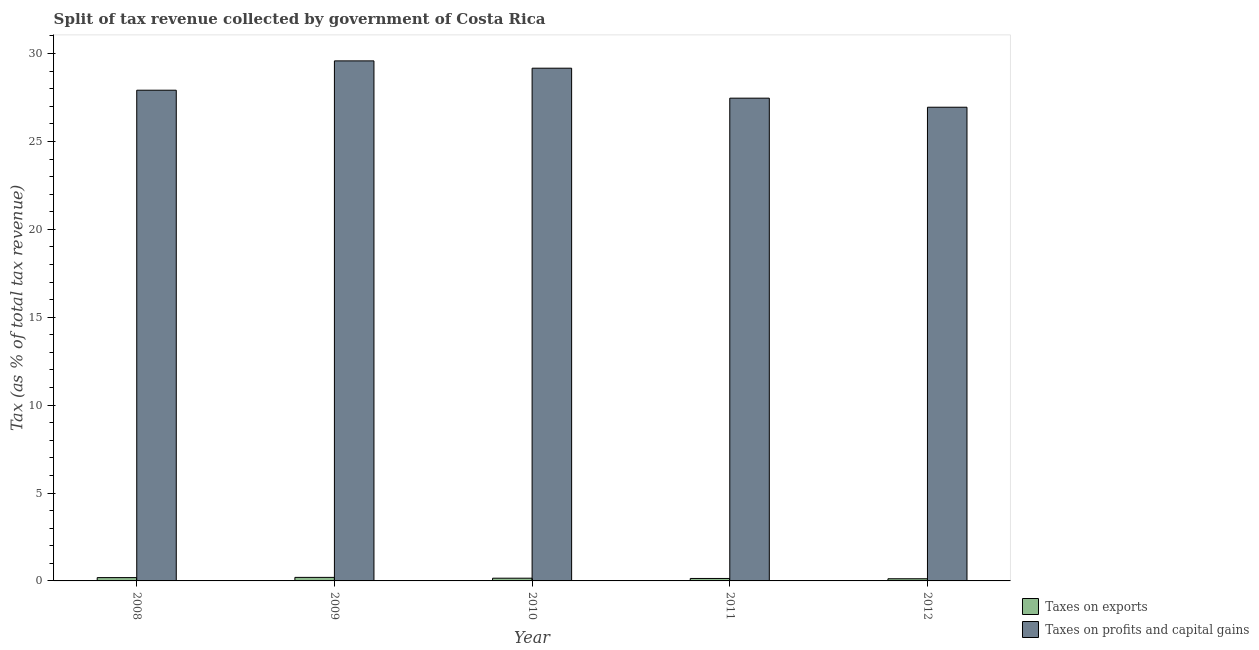How many different coloured bars are there?
Make the answer very short. 2. How many groups of bars are there?
Your response must be concise. 5. How many bars are there on the 4th tick from the right?
Your answer should be compact. 2. In how many cases, is the number of bars for a given year not equal to the number of legend labels?
Your response must be concise. 0. What is the percentage of revenue obtained from taxes on exports in 2010?
Your response must be concise. 0.15. Across all years, what is the maximum percentage of revenue obtained from taxes on profits and capital gains?
Keep it short and to the point. 29.58. Across all years, what is the minimum percentage of revenue obtained from taxes on profits and capital gains?
Provide a short and direct response. 26.95. In which year was the percentage of revenue obtained from taxes on profits and capital gains maximum?
Offer a terse response. 2009. In which year was the percentage of revenue obtained from taxes on profits and capital gains minimum?
Ensure brevity in your answer.  2012. What is the total percentage of revenue obtained from taxes on exports in the graph?
Make the answer very short. 0.81. What is the difference between the percentage of revenue obtained from taxes on exports in 2008 and that in 2012?
Offer a very short reply. 0.07. What is the difference between the percentage of revenue obtained from taxes on exports in 2008 and the percentage of revenue obtained from taxes on profits and capital gains in 2012?
Keep it short and to the point. 0.07. What is the average percentage of revenue obtained from taxes on exports per year?
Keep it short and to the point. 0.16. In how many years, is the percentage of revenue obtained from taxes on profits and capital gains greater than 8 %?
Give a very brief answer. 5. What is the ratio of the percentage of revenue obtained from taxes on exports in 2008 to that in 2011?
Ensure brevity in your answer.  1.35. Is the percentage of revenue obtained from taxes on exports in 2009 less than that in 2012?
Make the answer very short. No. Is the difference between the percentage of revenue obtained from taxes on profits and capital gains in 2008 and 2009 greater than the difference between the percentage of revenue obtained from taxes on exports in 2008 and 2009?
Provide a short and direct response. No. What is the difference between the highest and the second highest percentage of revenue obtained from taxes on profits and capital gains?
Your answer should be very brief. 0.42. What is the difference between the highest and the lowest percentage of revenue obtained from taxes on exports?
Your answer should be compact. 0.08. Is the sum of the percentage of revenue obtained from taxes on exports in 2009 and 2011 greater than the maximum percentage of revenue obtained from taxes on profits and capital gains across all years?
Keep it short and to the point. Yes. What does the 2nd bar from the left in 2011 represents?
Give a very brief answer. Taxes on profits and capital gains. What does the 2nd bar from the right in 2009 represents?
Your answer should be very brief. Taxes on exports. What is the difference between two consecutive major ticks on the Y-axis?
Offer a terse response. 5. Are the values on the major ticks of Y-axis written in scientific E-notation?
Provide a short and direct response. No. Does the graph contain any zero values?
Offer a very short reply. No. Does the graph contain grids?
Ensure brevity in your answer.  No. How many legend labels are there?
Provide a short and direct response. 2. How are the legend labels stacked?
Ensure brevity in your answer.  Vertical. What is the title of the graph?
Your response must be concise. Split of tax revenue collected by government of Costa Rica. What is the label or title of the X-axis?
Offer a very short reply. Year. What is the label or title of the Y-axis?
Ensure brevity in your answer.  Tax (as % of total tax revenue). What is the Tax (as % of total tax revenue) of Taxes on exports in 2008?
Your response must be concise. 0.19. What is the Tax (as % of total tax revenue) of Taxes on profits and capital gains in 2008?
Your answer should be very brief. 27.91. What is the Tax (as % of total tax revenue) in Taxes on exports in 2009?
Your response must be concise. 0.2. What is the Tax (as % of total tax revenue) in Taxes on profits and capital gains in 2009?
Keep it short and to the point. 29.58. What is the Tax (as % of total tax revenue) of Taxes on exports in 2010?
Your response must be concise. 0.15. What is the Tax (as % of total tax revenue) in Taxes on profits and capital gains in 2010?
Provide a short and direct response. 29.17. What is the Tax (as % of total tax revenue) in Taxes on exports in 2011?
Provide a succinct answer. 0.14. What is the Tax (as % of total tax revenue) of Taxes on profits and capital gains in 2011?
Offer a terse response. 27.46. What is the Tax (as % of total tax revenue) of Taxes on exports in 2012?
Ensure brevity in your answer.  0.12. What is the Tax (as % of total tax revenue) in Taxes on profits and capital gains in 2012?
Keep it short and to the point. 26.95. Across all years, what is the maximum Tax (as % of total tax revenue) in Taxes on exports?
Make the answer very short. 0.2. Across all years, what is the maximum Tax (as % of total tax revenue) in Taxes on profits and capital gains?
Offer a very short reply. 29.58. Across all years, what is the minimum Tax (as % of total tax revenue) in Taxes on exports?
Keep it short and to the point. 0.12. Across all years, what is the minimum Tax (as % of total tax revenue) in Taxes on profits and capital gains?
Your response must be concise. 26.95. What is the total Tax (as % of total tax revenue) of Taxes on exports in the graph?
Make the answer very short. 0.81. What is the total Tax (as % of total tax revenue) of Taxes on profits and capital gains in the graph?
Your response must be concise. 141.07. What is the difference between the Tax (as % of total tax revenue) in Taxes on exports in 2008 and that in 2009?
Provide a short and direct response. -0.01. What is the difference between the Tax (as % of total tax revenue) of Taxes on profits and capital gains in 2008 and that in 2009?
Your answer should be very brief. -1.67. What is the difference between the Tax (as % of total tax revenue) in Taxes on exports in 2008 and that in 2010?
Your response must be concise. 0.03. What is the difference between the Tax (as % of total tax revenue) in Taxes on profits and capital gains in 2008 and that in 2010?
Provide a succinct answer. -1.25. What is the difference between the Tax (as % of total tax revenue) of Taxes on exports in 2008 and that in 2011?
Provide a short and direct response. 0.05. What is the difference between the Tax (as % of total tax revenue) of Taxes on profits and capital gains in 2008 and that in 2011?
Your answer should be compact. 0.45. What is the difference between the Tax (as % of total tax revenue) of Taxes on exports in 2008 and that in 2012?
Offer a very short reply. 0.07. What is the difference between the Tax (as % of total tax revenue) of Taxes on profits and capital gains in 2008 and that in 2012?
Offer a terse response. 0.97. What is the difference between the Tax (as % of total tax revenue) of Taxes on exports in 2009 and that in 2010?
Your answer should be very brief. 0.05. What is the difference between the Tax (as % of total tax revenue) in Taxes on profits and capital gains in 2009 and that in 2010?
Offer a terse response. 0.42. What is the difference between the Tax (as % of total tax revenue) in Taxes on exports in 2009 and that in 2011?
Provide a short and direct response. 0.06. What is the difference between the Tax (as % of total tax revenue) of Taxes on profits and capital gains in 2009 and that in 2011?
Keep it short and to the point. 2.12. What is the difference between the Tax (as % of total tax revenue) in Taxes on exports in 2009 and that in 2012?
Keep it short and to the point. 0.08. What is the difference between the Tax (as % of total tax revenue) in Taxes on profits and capital gains in 2009 and that in 2012?
Ensure brevity in your answer.  2.64. What is the difference between the Tax (as % of total tax revenue) in Taxes on exports in 2010 and that in 2011?
Your answer should be compact. 0.02. What is the difference between the Tax (as % of total tax revenue) in Taxes on profits and capital gains in 2010 and that in 2011?
Offer a very short reply. 1.7. What is the difference between the Tax (as % of total tax revenue) of Taxes on exports in 2010 and that in 2012?
Your answer should be very brief. 0.03. What is the difference between the Tax (as % of total tax revenue) in Taxes on profits and capital gains in 2010 and that in 2012?
Your answer should be very brief. 2.22. What is the difference between the Tax (as % of total tax revenue) in Taxes on exports in 2011 and that in 2012?
Give a very brief answer. 0.02. What is the difference between the Tax (as % of total tax revenue) of Taxes on profits and capital gains in 2011 and that in 2012?
Provide a succinct answer. 0.52. What is the difference between the Tax (as % of total tax revenue) of Taxes on exports in 2008 and the Tax (as % of total tax revenue) of Taxes on profits and capital gains in 2009?
Keep it short and to the point. -29.39. What is the difference between the Tax (as % of total tax revenue) of Taxes on exports in 2008 and the Tax (as % of total tax revenue) of Taxes on profits and capital gains in 2010?
Your answer should be compact. -28.98. What is the difference between the Tax (as % of total tax revenue) in Taxes on exports in 2008 and the Tax (as % of total tax revenue) in Taxes on profits and capital gains in 2011?
Your answer should be compact. -27.27. What is the difference between the Tax (as % of total tax revenue) of Taxes on exports in 2008 and the Tax (as % of total tax revenue) of Taxes on profits and capital gains in 2012?
Provide a succinct answer. -26.76. What is the difference between the Tax (as % of total tax revenue) in Taxes on exports in 2009 and the Tax (as % of total tax revenue) in Taxes on profits and capital gains in 2010?
Your response must be concise. -28.97. What is the difference between the Tax (as % of total tax revenue) in Taxes on exports in 2009 and the Tax (as % of total tax revenue) in Taxes on profits and capital gains in 2011?
Offer a very short reply. -27.26. What is the difference between the Tax (as % of total tax revenue) of Taxes on exports in 2009 and the Tax (as % of total tax revenue) of Taxes on profits and capital gains in 2012?
Ensure brevity in your answer.  -26.75. What is the difference between the Tax (as % of total tax revenue) of Taxes on exports in 2010 and the Tax (as % of total tax revenue) of Taxes on profits and capital gains in 2011?
Ensure brevity in your answer.  -27.31. What is the difference between the Tax (as % of total tax revenue) in Taxes on exports in 2010 and the Tax (as % of total tax revenue) in Taxes on profits and capital gains in 2012?
Provide a short and direct response. -26.79. What is the difference between the Tax (as % of total tax revenue) of Taxes on exports in 2011 and the Tax (as % of total tax revenue) of Taxes on profits and capital gains in 2012?
Your answer should be very brief. -26.81. What is the average Tax (as % of total tax revenue) of Taxes on exports per year?
Your answer should be compact. 0.16. What is the average Tax (as % of total tax revenue) of Taxes on profits and capital gains per year?
Ensure brevity in your answer.  28.21. In the year 2008, what is the difference between the Tax (as % of total tax revenue) of Taxes on exports and Tax (as % of total tax revenue) of Taxes on profits and capital gains?
Your answer should be compact. -27.73. In the year 2009, what is the difference between the Tax (as % of total tax revenue) of Taxes on exports and Tax (as % of total tax revenue) of Taxes on profits and capital gains?
Your response must be concise. -29.38. In the year 2010, what is the difference between the Tax (as % of total tax revenue) of Taxes on exports and Tax (as % of total tax revenue) of Taxes on profits and capital gains?
Offer a terse response. -29.01. In the year 2011, what is the difference between the Tax (as % of total tax revenue) of Taxes on exports and Tax (as % of total tax revenue) of Taxes on profits and capital gains?
Make the answer very short. -27.32. In the year 2012, what is the difference between the Tax (as % of total tax revenue) of Taxes on exports and Tax (as % of total tax revenue) of Taxes on profits and capital gains?
Your response must be concise. -26.82. What is the ratio of the Tax (as % of total tax revenue) of Taxes on exports in 2008 to that in 2009?
Make the answer very short. 0.94. What is the ratio of the Tax (as % of total tax revenue) of Taxes on profits and capital gains in 2008 to that in 2009?
Your answer should be very brief. 0.94. What is the ratio of the Tax (as % of total tax revenue) of Taxes on exports in 2008 to that in 2010?
Keep it short and to the point. 1.22. What is the ratio of the Tax (as % of total tax revenue) of Taxes on profits and capital gains in 2008 to that in 2010?
Make the answer very short. 0.96. What is the ratio of the Tax (as % of total tax revenue) of Taxes on exports in 2008 to that in 2011?
Keep it short and to the point. 1.35. What is the ratio of the Tax (as % of total tax revenue) of Taxes on profits and capital gains in 2008 to that in 2011?
Provide a succinct answer. 1.02. What is the ratio of the Tax (as % of total tax revenue) of Taxes on exports in 2008 to that in 2012?
Offer a terse response. 1.54. What is the ratio of the Tax (as % of total tax revenue) of Taxes on profits and capital gains in 2008 to that in 2012?
Offer a terse response. 1.04. What is the ratio of the Tax (as % of total tax revenue) of Taxes on exports in 2009 to that in 2010?
Ensure brevity in your answer.  1.3. What is the ratio of the Tax (as % of total tax revenue) in Taxes on profits and capital gains in 2009 to that in 2010?
Make the answer very short. 1.01. What is the ratio of the Tax (as % of total tax revenue) of Taxes on exports in 2009 to that in 2011?
Make the answer very short. 1.44. What is the ratio of the Tax (as % of total tax revenue) in Taxes on profits and capital gains in 2009 to that in 2011?
Offer a terse response. 1.08. What is the ratio of the Tax (as % of total tax revenue) of Taxes on exports in 2009 to that in 2012?
Your response must be concise. 1.64. What is the ratio of the Tax (as % of total tax revenue) in Taxes on profits and capital gains in 2009 to that in 2012?
Your response must be concise. 1.1. What is the ratio of the Tax (as % of total tax revenue) of Taxes on exports in 2010 to that in 2011?
Offer a terse response. 1.11. What is the ratio of the Tax (as % of total tax revenue) of Taxes on profits and capital gains in 2010 to that in 2011?
Provide a short and direct response. 1.06. What is the ratio of the Tax (as % of total tax revenue) in Taxes on exports in 2010 to that in 2012?
Make the answer very short. 1.26. What is the ratio of the Tax (as % of total tax revenue) in Taxes on profits and capital gains in 2010 to that in 2012?
Provide a succinct answer. 1.08. What is the ratio of the Tax (as % of total tax revenue) of Taxes on exports in 2011 to that in 2012?
Offer a terse response. 1.14. What is the ratio of the Tax (as % of total tax revenue) of Taxes on profits and capital gains in 2011 to that in 2012?
Make the answer very short. 1.02. What is the difference between the highest and the second highest Tax (as % of total tax revenue) in Taxes on exports?
Your answer should be very brief. 0.01. What is the difference between the highest and the second highest Tax (as % of total tax revenue) of Taxes on profits and capital gains?
Your response must be concise. 0.42. What is the difference between the highest and the lowest Tax (as % of total tax revenue) in Taxes on exports?
Give a very brief answer. 0.08. What is the difference between the highest and the lowest Tax (as % of total tax revenue) of Taxes on profits and capital gains?
Provide a succinct answer. 2.64. 